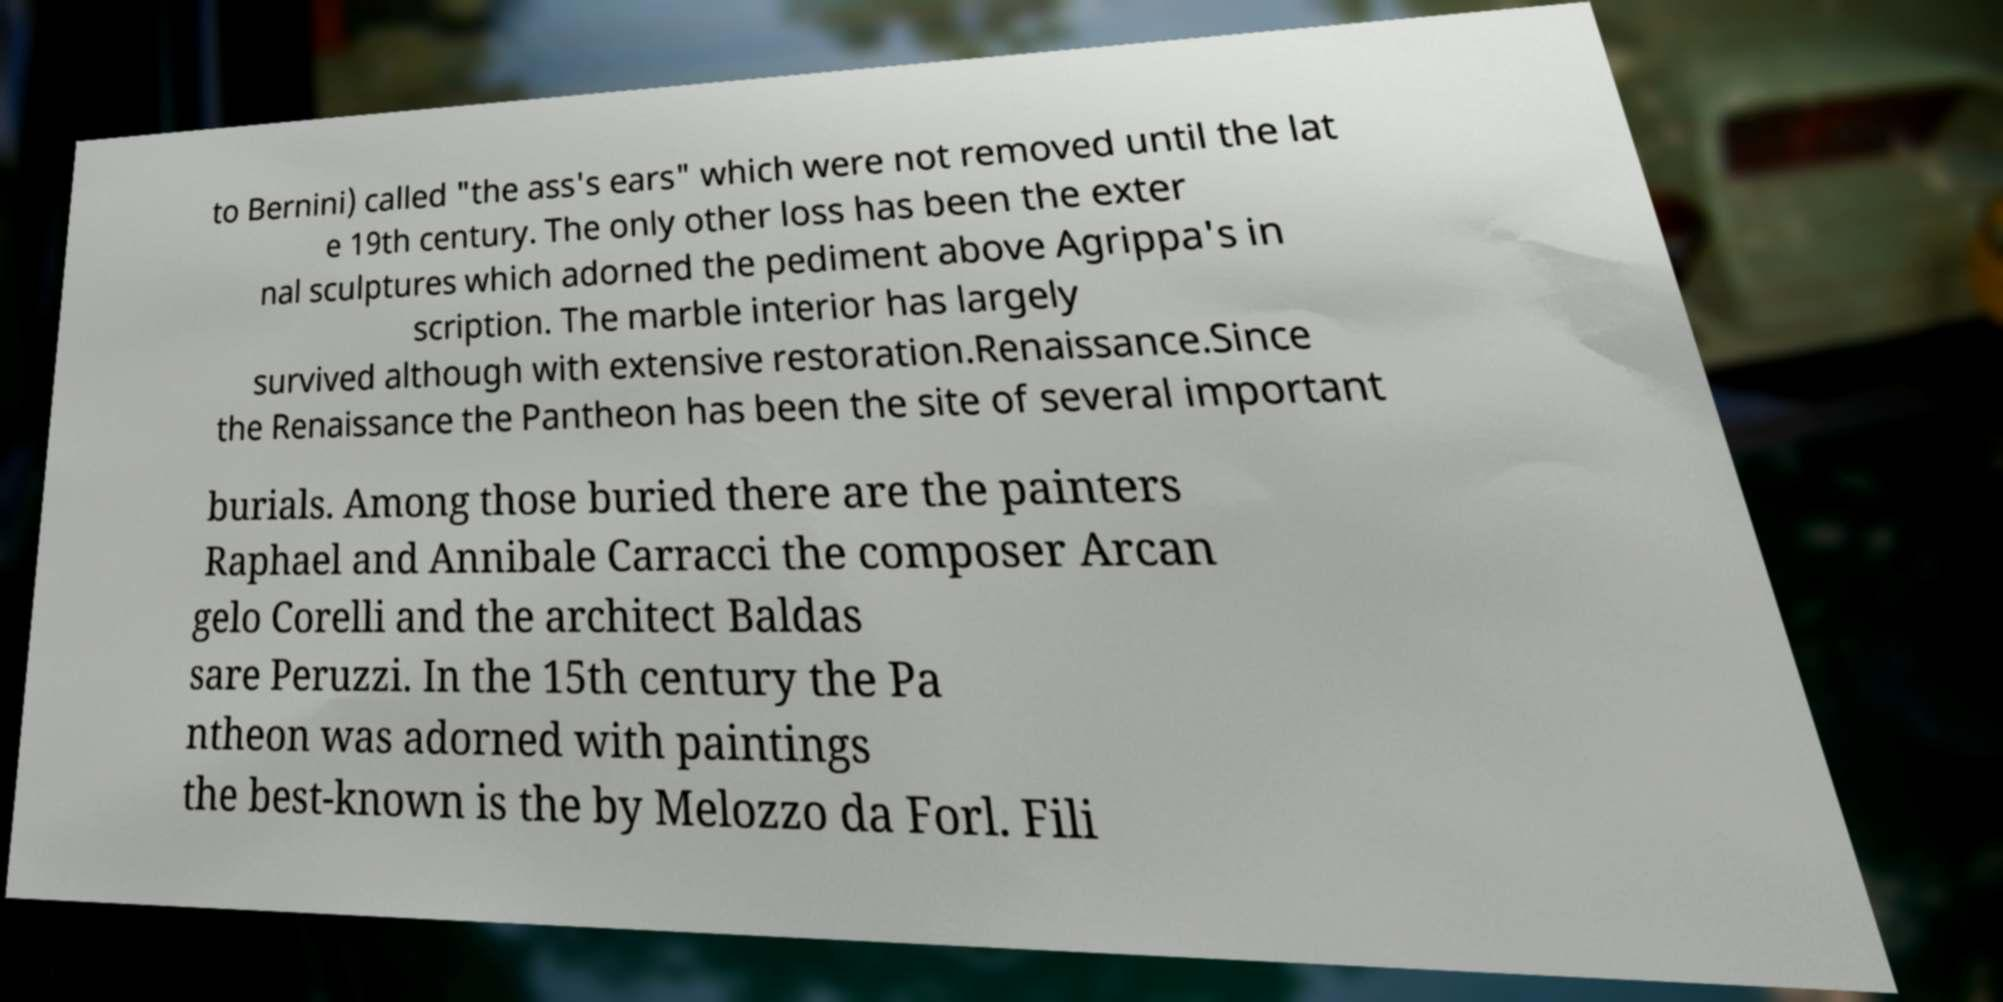Could you assist in decoding the text presented in this image and type it out clearly? to Bernini) called "the ass's ears" which were not removed until the lat e 19th century. The only other loss has been the exter nal sculptures which adorned the pediment above Agrippa's in scription. The marble interior has largely survived although with extensive restoration.Renaissance.Since the Renaissance the Pantheon has been the site of several important burials. Among those buried there are the painters Raphael and Annibale Carracci the composer Arcan gelo Corelli and the architect Baldas sare Peruzzi. In the 15th century the Pa ntheon was adorned with paintings the best-known is the by Melozzo da Forl. Fili 